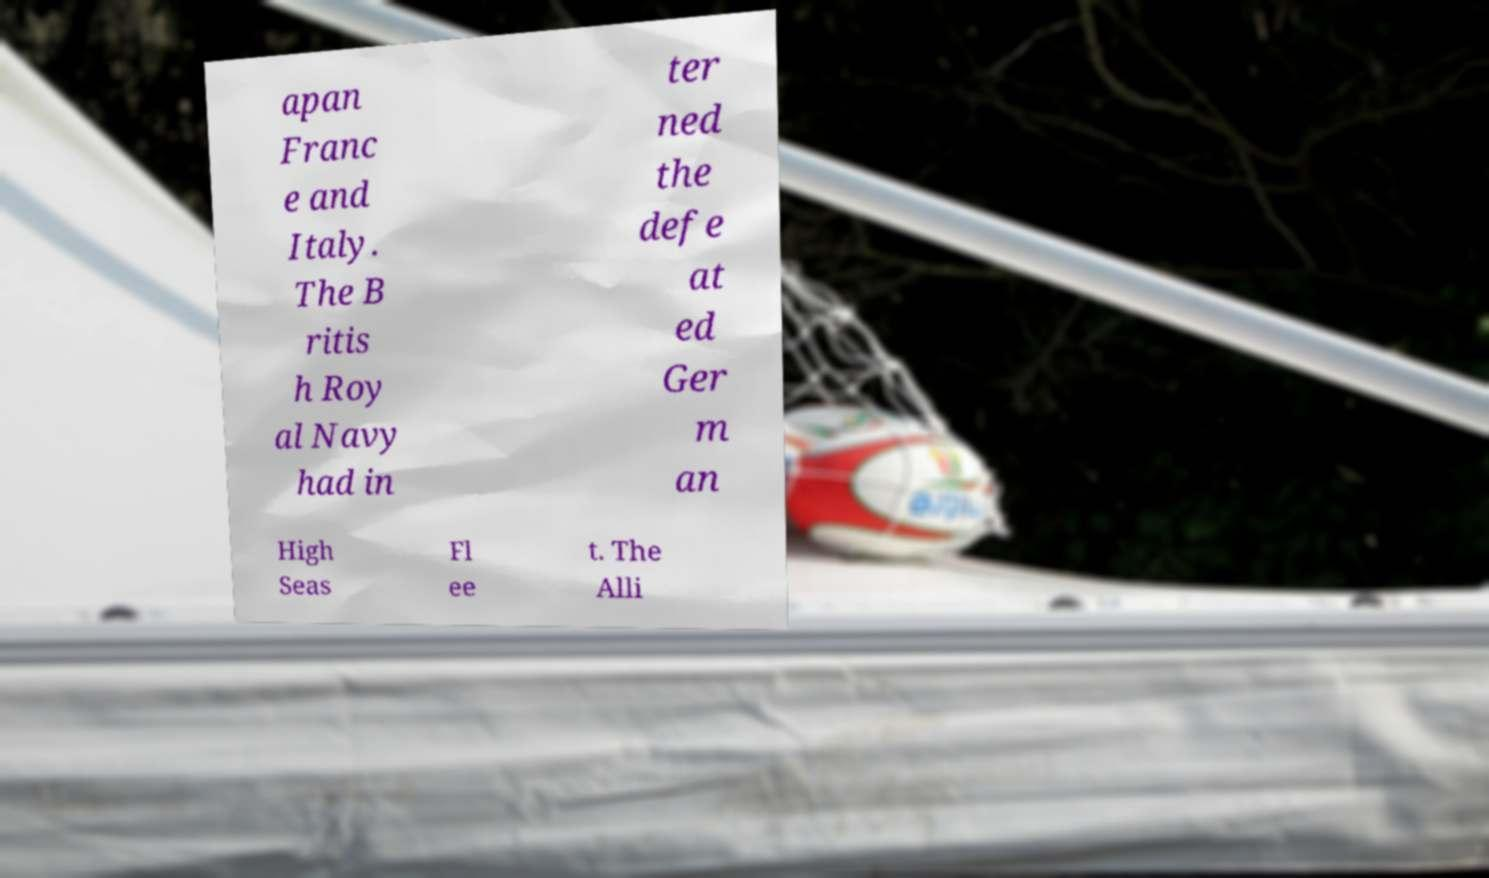What messages or text are displayed in this image? I need them in a readable, typed format. apan Franc e and Italy. The B ritis h Roy al Navy had in ter ned the defe at ed Ger m an High Seas Fl ee t. The Alli 